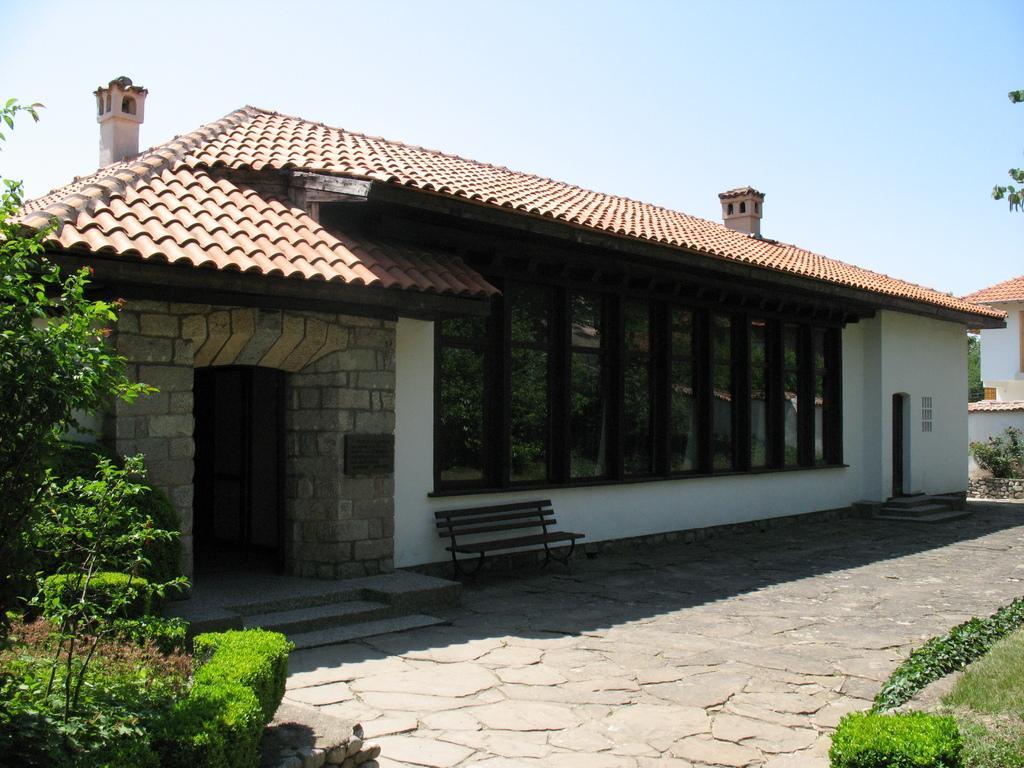Describe this image in one or two sentences. This looks like a house with the windows and doors. I can see a bench. This is a roof. These are the trees and bushes. On the right corner of the image, I can see another house. This is the sky. 